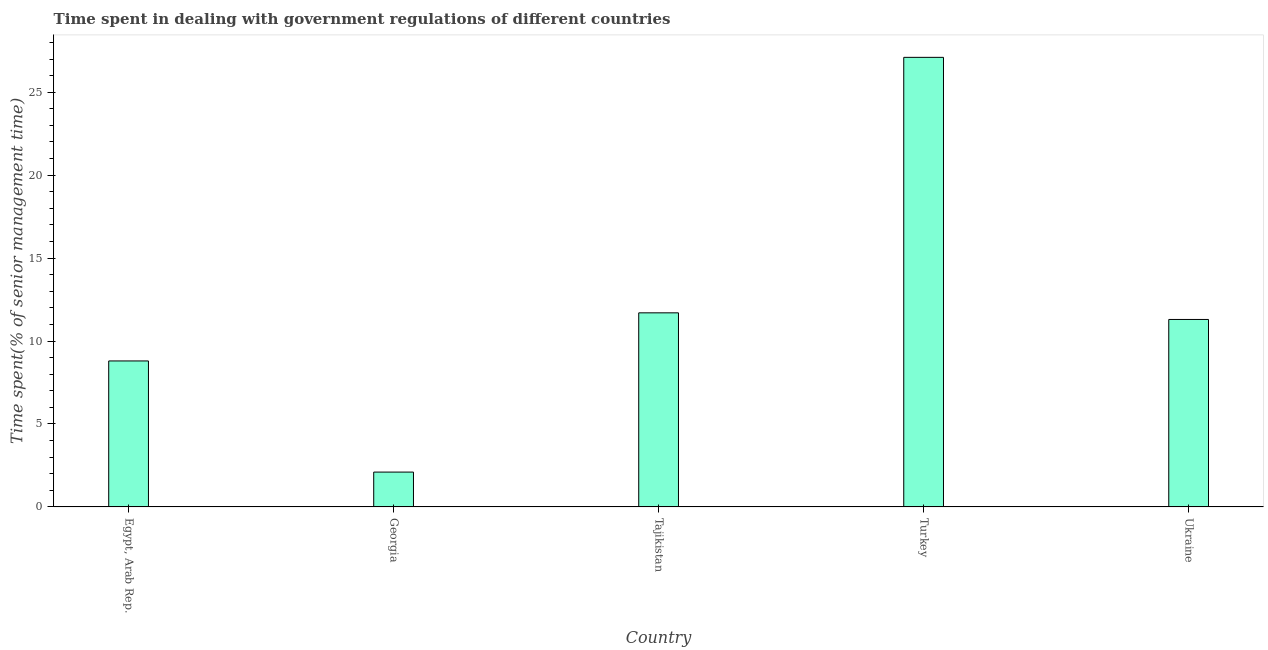Does the graph contain any zero values?
Your answer should be very brief. No. What is the title of the graph?
Your response must be concise. Time spent in dealing with government regulations of different countries. What is the label or title of the Y-axis?
Make the answer very short. Time spent(% of senior management time). What is the time spent in dealing with government regulations in Ukraine?
Offer a very short reply. 11.3. Across all countries, what is the maximum time spent in dealing with government regulations?
Give a very brief answer. 27.1. Across all countries, what is the minimum time spent in dealing with government regulations?
Your answer should be very brief. 2.1. In which country was the time spent in dealing with government regulations minimum?
Provide a succinct answer. Georgia. What is the sum of the time spent in dealing with government regulations?
Provide a succinct answer. 61. What is the difference between the time spent in dealing with government regulations in Egypt, Arab Rep. and Turkey?
Your response must be concise. -18.3. What is the median time spent in dealing with government regulations?
Provide a succinct answer. 11.3. What is the ratio of the time spent in dealing with government regulations in Egypt, Arab Rep. to that in Turkey?
Ensure brevity in your answer.  0.33. Is the difference between the time spent in dealing with government regulations in Egypt, Arab Rep. and Ukraine greater than the difference between any two countries?
Ensure brevity in your answer.  No. What is the difference between the highest and the second highest time spent in dealing with government regulations?
Your response must be concise. 15.4. Is the sum of the time spent in dealing with government regulations in Egypt, Arab Rep. and Tajikistan greater than the maximum time spent in dealing with government regulations across all countries?
Provide a succinct answer. No. How many bars are there?
Keep it short and to the point. 5. Are all the bars in the graph horizontal?
Make the answer very short. No. What is the difference between two consecutive major ticks on the Y-axis?
Ensure brevity in your answer.  5. What is the Time spent(% of senior management time) of Egypt, Arab Rep.?
Provide a short and direct response. 8.8. What is the Time spent(% of senior management time) in Georgia?
Ensure brevity in your answer.  2.1. What is the Time spent(% of senior management time) of Turkey?
Provide a succinct answer. 27.1. What is the difference between the Time spent(% of senior management time) in Egypt, Arab Rep. and Georgia?
Offer a very short reply. 6.7. What is the difference between the Time spent(% of senior management time) in Egypt, Arab Rep. and Turkey?
Your answer should be very brief. -18.3. What is the difference between the Time spent(% of senior management time) in Egypt, Arab Rep. and Ukraine?
Provide a short and direct response. -2.5. What is the difference between the Time spent(% of senior management time) in Georgia and Tajikistan?
Offer a terse response. -9.6. What is the difference between the Time spent(% of senior management time) in Tajikistan and Turkey?
Ensure brevity in your answer.  -15.4. What is the difference between the Time spent(% of senior management time) in Turkey and Ukraine?
Make the answer very short. 15.8. What is the ratio of the Time spent(% of senior management time) in Egypt, Arab Rep. to that in Georgia?
Ensure brevity in your answer.  4.19. What is the ratio of the Time spent(% of senior management time) in Egypt, Arab Rep. to that in Tajikistan?
Provide a short and direct response. 0.75. What is the ratio of the Time spent(% of senior management time) in Egypt, Arab Rep. to that in Turkey?
Provide a short and direct response. 0.33. What is the ratio of the Time spent(% of senior management time) in Egypt, Arab Rep. to that in Ukraine?
Offer a terse response. 0.78. What is the ratio of the Time spent(% of senior management time) in Georgia to that in Tajikistan?
Make the answer very short. 0.18. What is the ratio of the Time spent(% of senior management time) in Georgia to that in Turkey?
Provide a short and direct response. 0.08. What is the ratio of the Time spent(% of senior management time) in Georgia to that in Ukraine?
Offer a terse response. 0.19. What is the ratio of the Time spent(% of senior management time) in Tajikistan to that in Turkey?
Provide a short and direct response. 0.43. What is the ratio of the Time spent(% of senior management time) in Tajikistan to that in Ukraine?
Your answer should be compact. 1.03. What is the ratio of the Time spent(% of senior management time) in Turkey to that in Ukraine?
Keep it short and to the point. 2.4. 